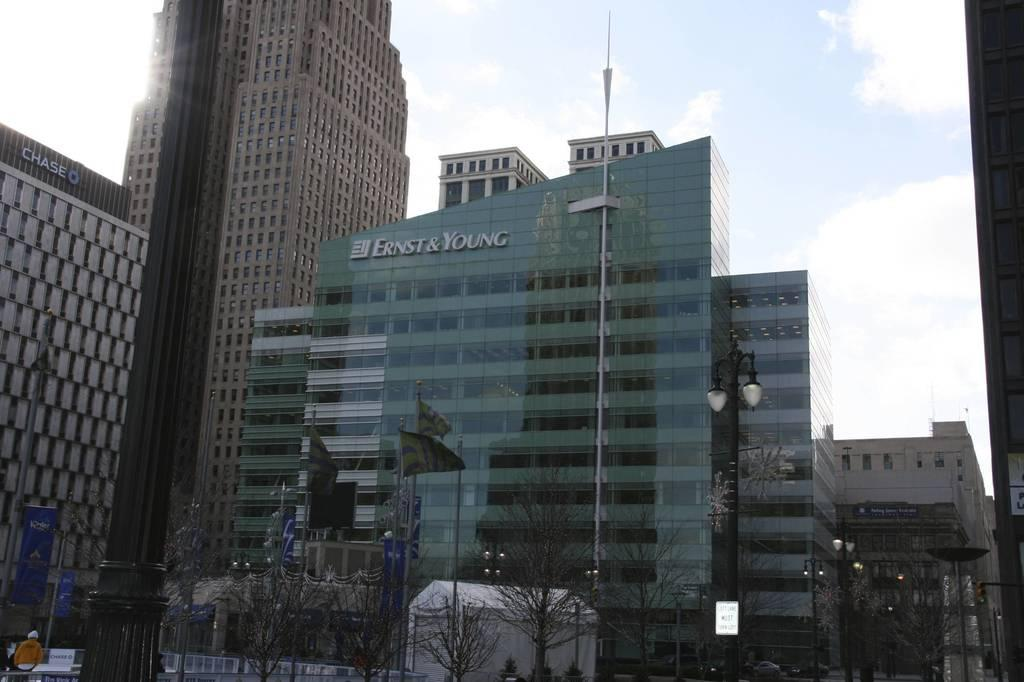What type of structures can be seen in the image? There are buildings in the image. What other objects are present in the image? There are poles, lights, trees, flags, boards, and banners in the image. What can be seen in the background of the image? The sky is visible in the background of the image, with clouds present. What type of coat is the brother wearing in the image? There is no brother or coat present in the image. What is located at the front of the image? The provided facts do not specify any particular object or subject as being at the front of the image. 